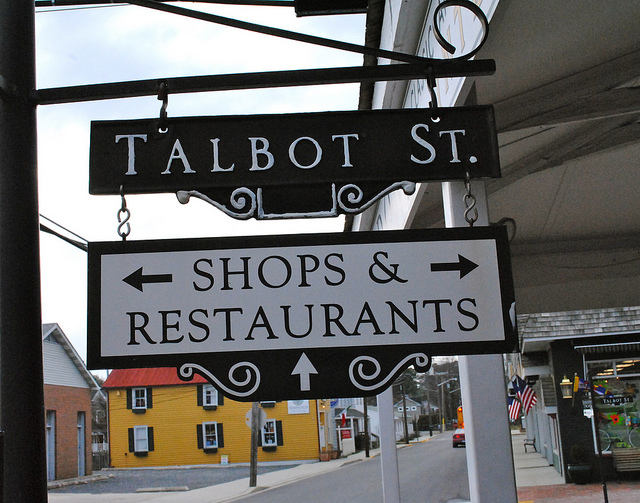<image>What flags fly in this photo? It is ambiguous to know what flags fly in the photo since there is no image. But, it could be an American flag. What flags fly in this photo? I don't know what flags fly in this photo. It could be American flags. 